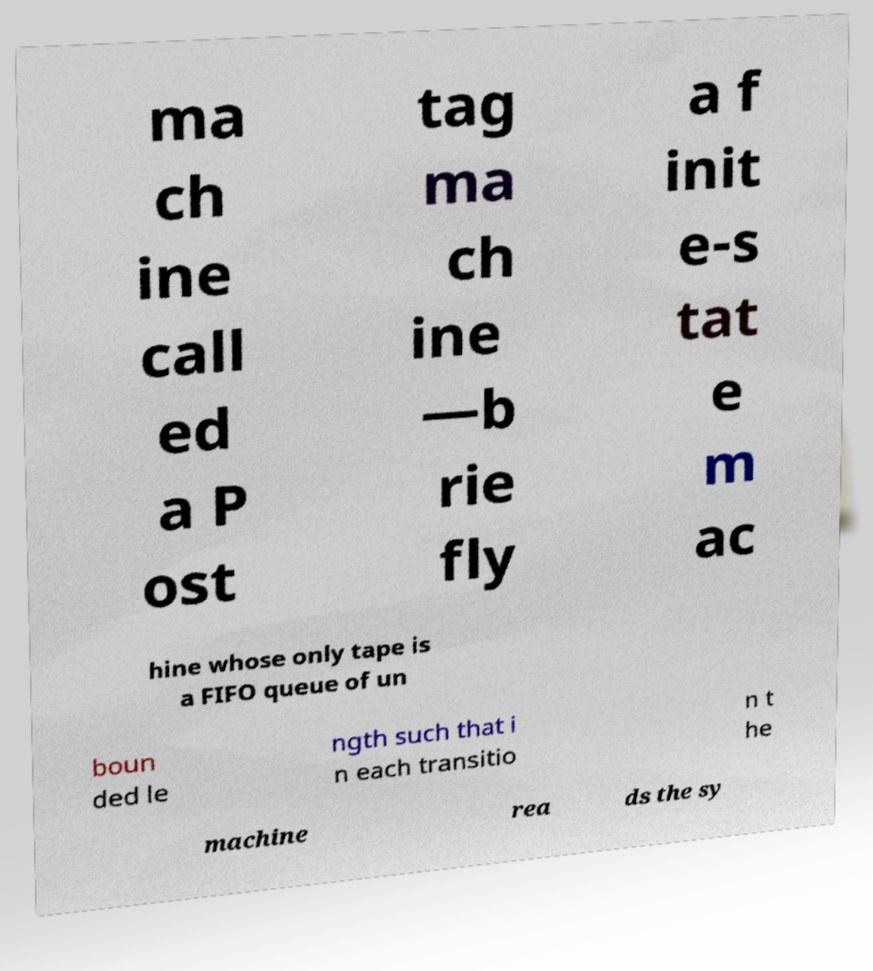Please identify and transcribe the text found in this image. ma ch ine call ed a P ost tag ma ch ine —b rie fly a f init e-s tat e m ac hine whose only tape is a FIFO queue of un boun ded le ngth such that i n each transitio n t he machine rea ds the sy 